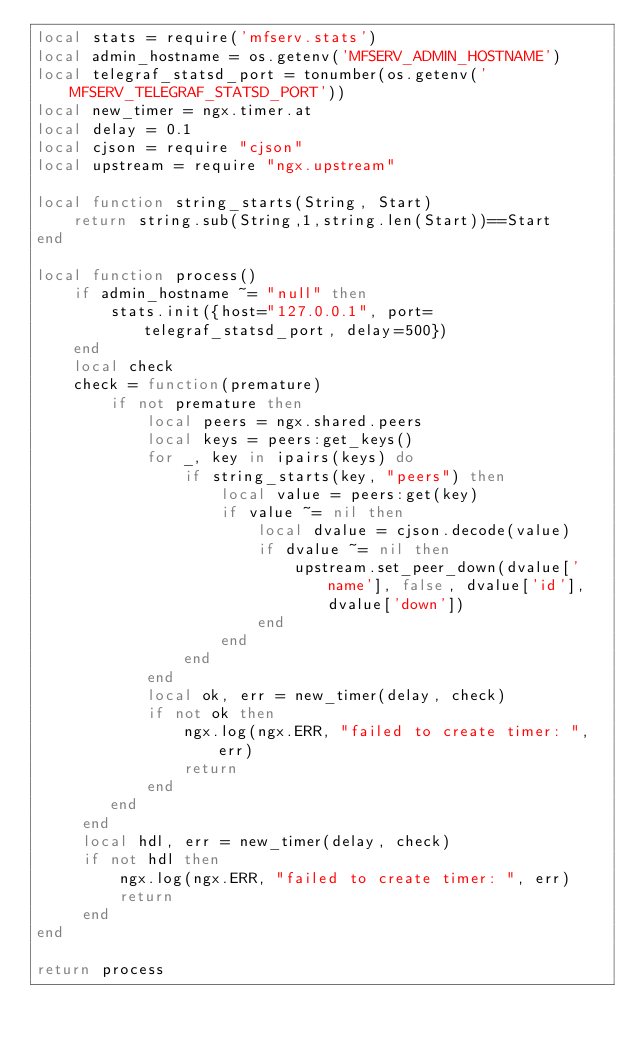Convert code to text. <code><loc_0><loc_0><loc_500><loc_500><_Lua_>local stats = require('mfserv.stats')
local admin_hostname = os.getenv('MFSERV_ADMIN_HOSTNAME')
local telegraf_statsd_port = tonumber(os.getenv('MFSERV_TELEGRAF_STATSD_PORT'))
local new_timer = ngx.timer.at
local delay = 0.1
local cjson = require "cjson"
local upstream = require "ngx.upstream"

local function string_starts(String, Start)
    return string.sub(String,1,string.len(Start))==Start
end

local function process()
    if admin_hostname ~= "null" then
        stats.init({host="127.0.0.1", port=telegraf_statsd_port, delay=500})
    end
    local check
    check = function(premature)
        if not premature then
            local peers = ngx.shared.peers
            local keys = peers:get_keys()
            for _, key in ipairs(keys) do
                if string_starts(key, "peers") then
                    local value = peers:get(key)
                    if value ~= nil then
                        local dvalue = cjson.decode(value)
                        if dvalue ~= nil then
                            upstream.set_peer_down(dvalue['name'], false, dvalue['id'], dvalue['down'])
                        end
                    end
                end
            end
            local ok, err = new_timer(delay, check)
            if not ok then
                ngx.log(ngx.ERR, "failed to create timer: ", err)
                return
            end
        end
     end
     local hdl, err = new_timer(delay, check)
     if not hdl then
         ngx.log(ngx.ERR, "failed to create timer: ", err)
         return
     end
end

return process
</code> 